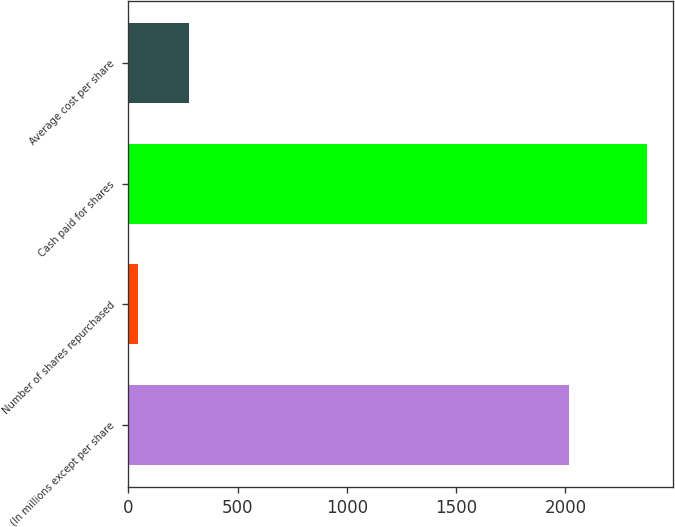<chart> <loc_0><loc_0><loc_500><loc_500><bar_chart><fcel>(In millions except per share<fcel>Number of shares repurchased<fcel>Cash paid for shares<fcel>Average cost per share<nl><fcel>2017<fcel>44<fcel>2372<fcel>276.8<nl></chart> 